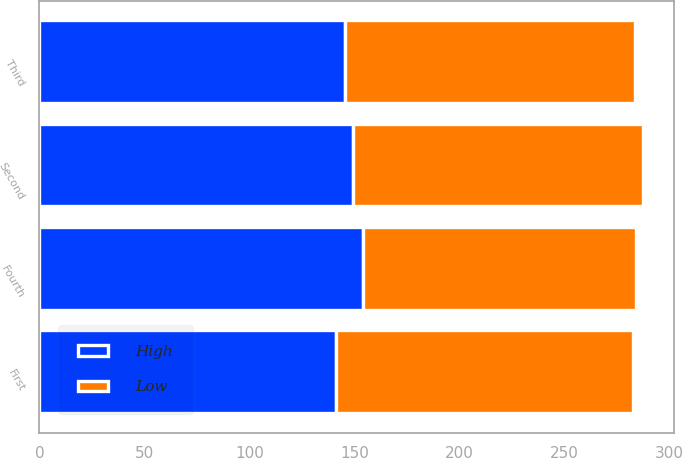Convert chart to OTSL. <chart><loc_0><loc_0><loc_500><loc_500><stacked_bar_chart><ecel><fcel>First<fcel>Second<fcel>Third<fcel>Fourth<nl><fcel>High<fcel>141.26<fcel>149.5<fcel>145.57<fcel>153.86<nl><fcel>Low<fcel>141.26<fcel>138.08<fcel>137.93<fcel>130.4<nl></chart> 